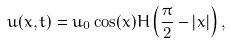<formula> <loc_0><loc_0><loc_500><loc_500>u ( x , t ) = u _ { 0 } \cos ( x ) H \left ( \frac { \pi } { 2 } - | x | \right ) ,</formula> 